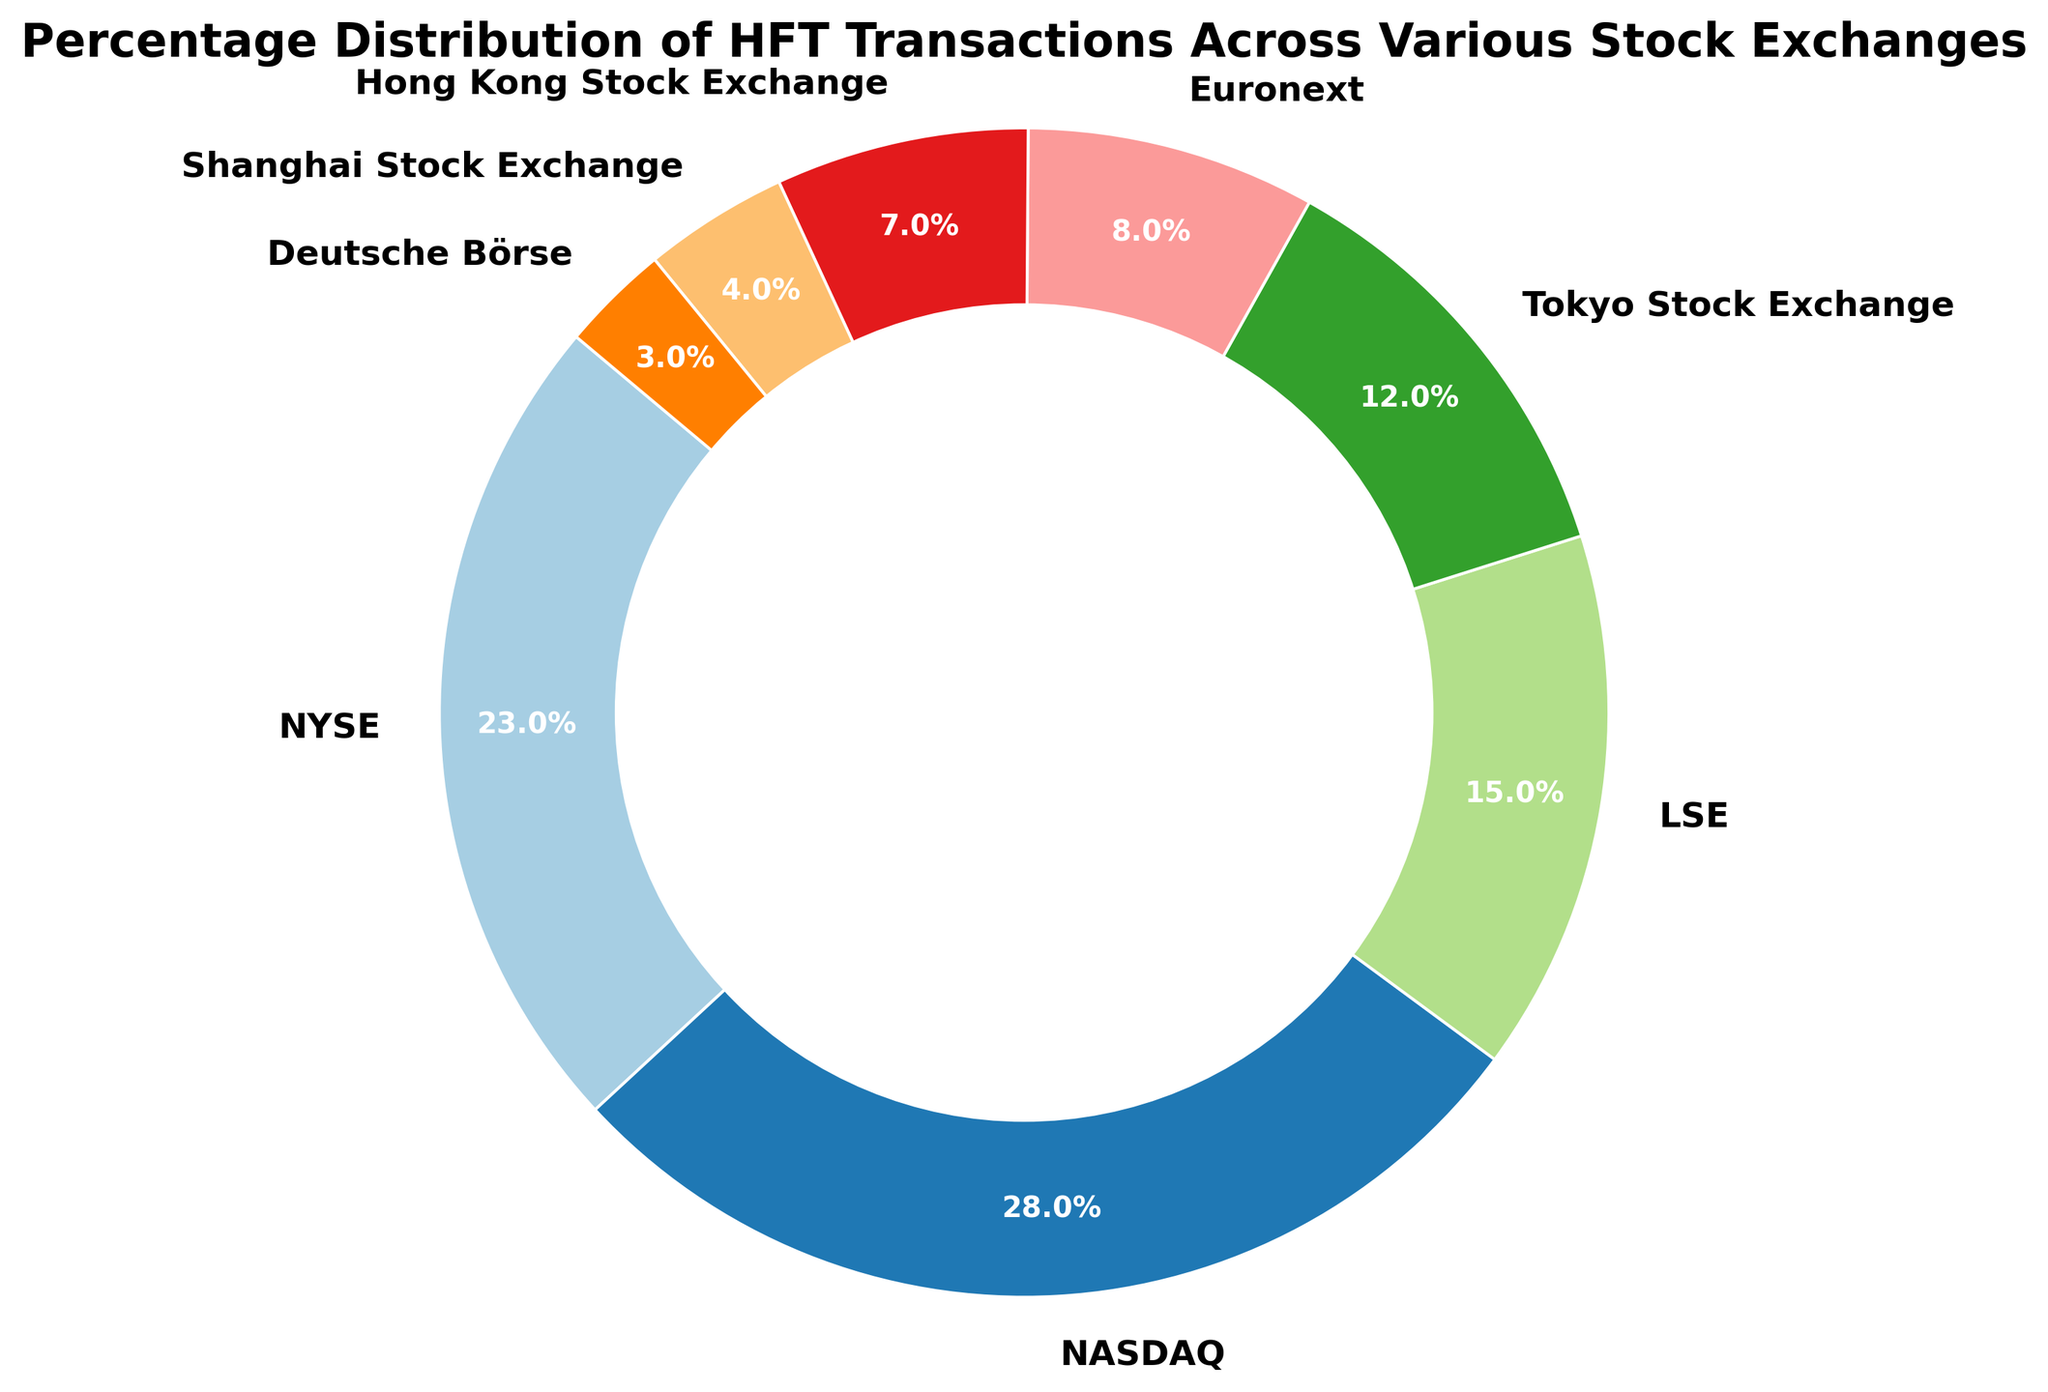What is the percentage of HFT transactions taking place on the NASDAQ? The pie chart shows the percentage distribution of HFT transactions across various stock exchanges. To find the NASDAQ percentage, locate the NASDAQ label and read the corresponding value, which is shown as 28%.
Answer: 28% Which stock exchange has the smallest percentage of HFT transactions? To find the stock exchange with the smallest percentage, review all the percentages shown and identify the lowest value. Shanghai Stock Exchange has the smallest percentage at 3%.
Answer: Shanghai Stock Exchange What is the combined percentage of HFT transactions for NYSE and NASDAQ? To find the combined percentage of NYSE and NASDAQ, add their individual percentages shown in the pie chart. NYSE has 23% and NASDAQ has 28%, so 23% + 28% = 51%.
Answer: 51% Which stock exchange has a higher percentage of HFT transactions, LSE or Tokyo Stock Exchange, and by how much? Identify the percentages for LSE and Tokyo Stock Exchange from the chart. LSE has 15% and Tokyo Stock Exchange has 12%. Subtract the smaller percentage from the larger to find the difference: 15% - 12% = 3%.
Answer: LSE has 3% more Are there any stock exchanges with equal percentages of HFT transactions? Carefully review the percentages associated with each stock exchange and compare them to identify any that are equal. The percentages are unique to each stock exchange, so there are no equal values.
Answer: No, there are no equal percentages Which two stock exchanges together make up approximately 20% of HFT transactions? To find the stock exchanges that together approximate 20%, look for two exchanges whose percentages sum to around 20%. Hong Kong Stock Exchange has 7% and Euronext has 8%, summing to 15%, while the Shanghai Stock Exchange has 4% adding up to 19%. The closest exact pair are Hong Kong Stock Exchange and Shanghai Stock Exchange: 7% + 4% = 11%.
Answer: None add exactly to 20% What proportion of the total HFT transactions is done by the stock exchanges with more than 10% each? Identify the stock exchanges with more than 10% (NYSE, NASDAQ, LSE, Tokyo Stock Exchange). Add their percentages: 23% + 28% + 15% + 12% = 78%.
Answer: 78% Rank the stock exchanges from highest to lowest percentage of HFT transactions. List the stock exchanges in order of their percentage values from highest to lowest. NASDAQ (28%), NYSE (23%), LSE (15%), Tokyo Stock Exchange (12%), Euronext (8%), Hong Kong Stock Exchange (7%), Shanghai Stock Exchange (4%), Deutsche Börse (3%).
Answer: NASDAQ, NYSE, LSE, Tokyo Stock Exchange, Euronext, Hong Kong Stock Exchange, Shanghai Stock Exchange, Deutsche Börse 